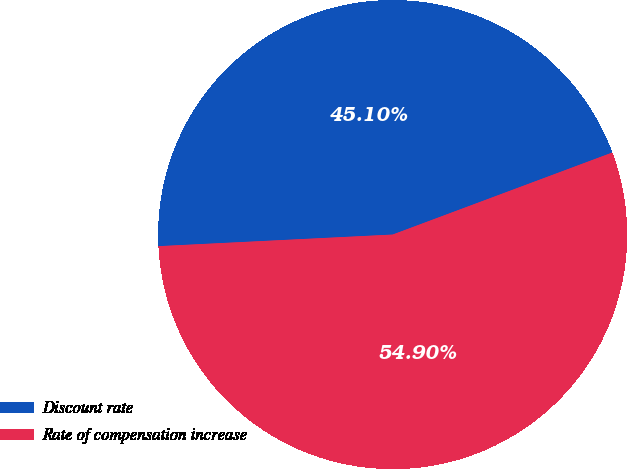<chart> <loc_0><loc_0><loc_500><loc_500><pie_chart><fcel>Discount rate<fcel>Rate of compensation increase<nl><fcel>45.1%<fcel>54.9%<nl></chart> 